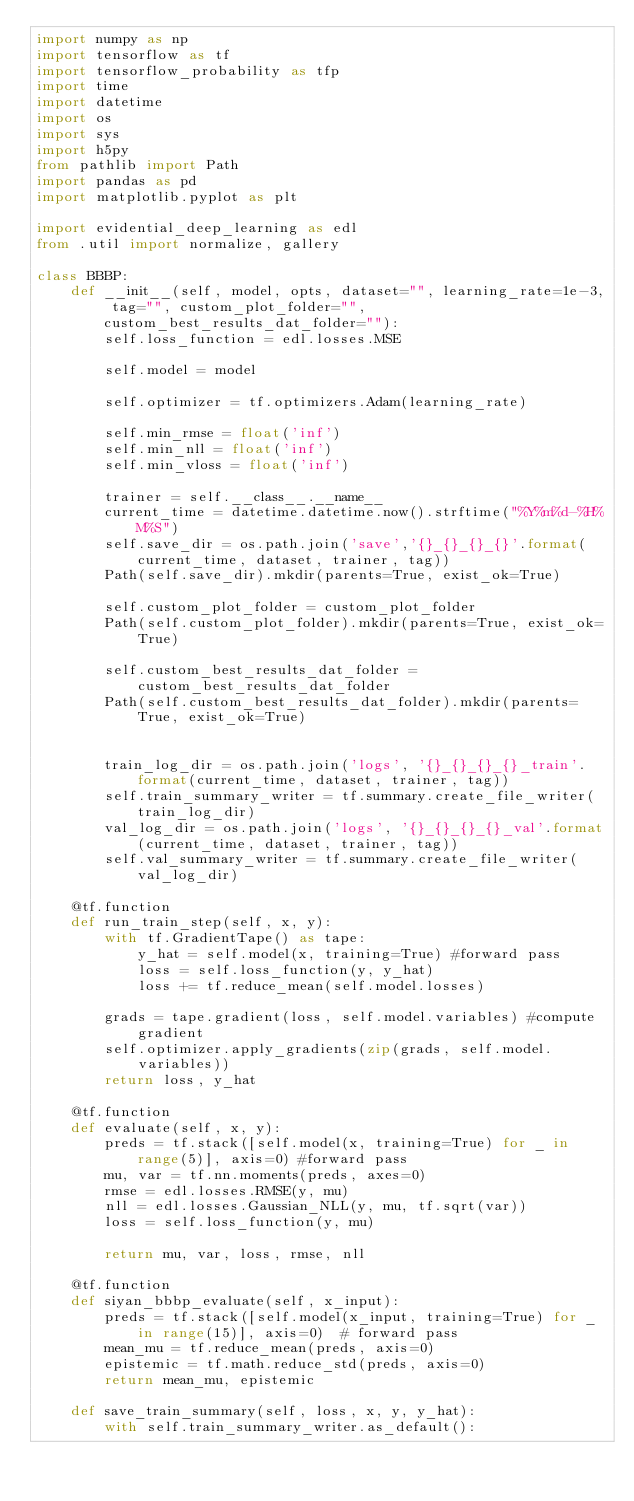<code> <loc_0><loc_0><loc_500><loc_500><_Python_>import numpy as np
import tensorflow as tf
import tensorflow_probability as tfp
import time
import datetime
import os
import sys
import h5py
from pathlib import Path
import pandas as pd
import matplotlib.pyplot as plt

import evidential_deep_learning as edl
from .util import normalize, gallery

class BBBP:
    def __init__(self, model, opts, dataset="", learning_rate=1e-3, tag="", custom_plot_folder="", custom_best_results_dat_folder=""):
        self.loss_function = edl.losses.MSE

        self.model = model

        self.optimizer = tf.optimizers.Adam(learning_rate)

        self.min_rmse = float('inf')
        self.min_nll = float('inf')
        self.min_vloss = float('inf')

        trainer = self.__class__.__name__
        current_time = datetime.datetime.now().strftime("%Y%m%d-%H%M%S")
        self.save_dir = os.path.join('save','{}_{}_{}_{}'.format(current_time, dataset, trainer, tag))
        Path(self.save_dir).mkdir(parents=True, exist_ok=True)

        self.custom_plot_folder = custom_plot_folder
        Path(self.custom_plot_folder).mkdir(parents=True, exist_ok=True)

        self.custom_best_results_dat_folder = custom_best_results_dat_folder
        Path(self.custom_best_results_dat_folder).mkdir(parents=True, exist_ok=True)


        train_log_dir = os.path.join('logs', '{}_{}_{}_{}_train'.format(current_time, dataset, trainer, tag))
        self.train_summary_writer = tf.summary.create_file_writer(train_log_dir)
        val_log_dir = os.path.join('logs', '{}_{}_{}_{}_val'.format(current_time, dataset, trainer, tag))
        self.val_summary_writer = tf.summary.create_file_writer(val_log_dir)

    @tf.function
    def run_train_step(self, x, y):
        with tf.GradientTape() as tape:
            y_hat = self.model(x, training=True) #forward pass
            loss = self.loss_function(y, y_hat)
            loss += tf.reduce_mean(self.model.losses)

        grads = tape.gradient(loss, self.model.variables) #compute gradient
        self.optimizer.apply_gradients(zip(grads, self.model.variables))
        return loss, y_hat

    @tf.function
    def evaluate(self, x, y):
        preds = tf.stack([self.model(x, training=True) for _ in range(5)], axis=0) #forward pass
        mu, var = tf.nn.moments(preds, axes=0)
        rmse = edl.losses.RMSE(y, mu)
        nll = edl.losses.Gaussian_NLL(y, mu, tf.sqrt(var))
        loss = self.loss_function(y, mu)

        return mu, var, loss, rmse, nll

    @tf.function
    def siyan_bbbp_evaluate(self, x_input):
        preds = tf.stack([self.model(x_input, training=True) for _ in range(15)], axis=0)  # forward pass
        mean_mu = tf.reduce_mean(preds, axis=0)
        epistemic = tf.math.reduce_std(preds, axis=0)
        return mean_mu, epistemic

    def save_train_summary(self, loss, x, y, y_hat):
        with self.train_summary_writer.as_default():</code> 